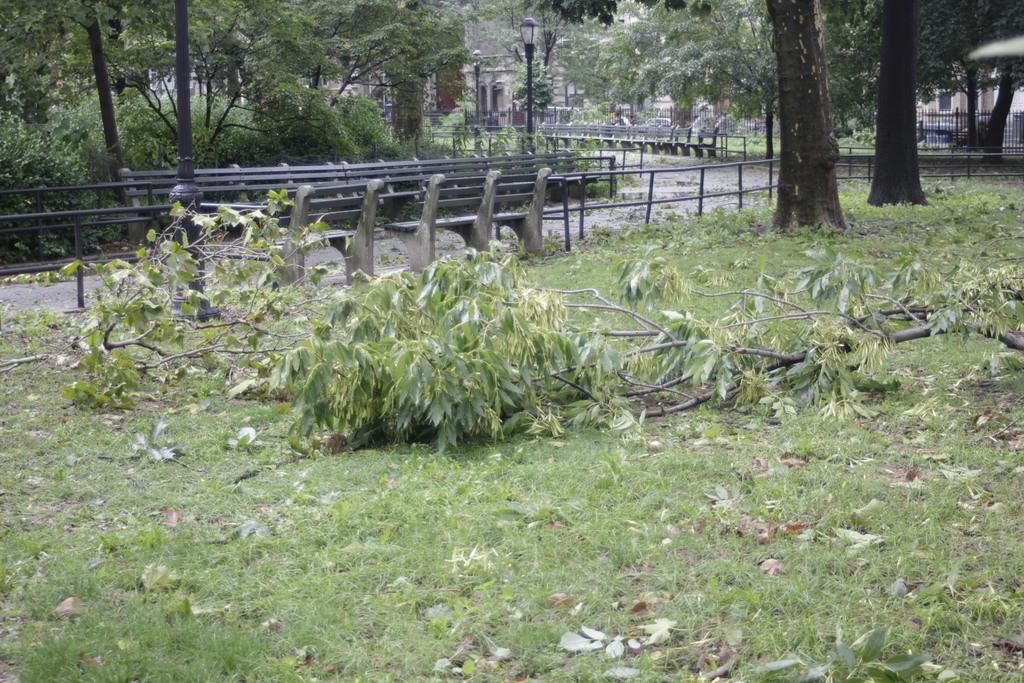What is on the grassy land in the image? There is a branch of a tree on the grassy land. What can be seen in the background of the image? There are benches, a fence, a pole, lights, and trees in the background. What is present on the grassy land besides the branch? There are dry leaves on the grassy land. Can you touch the kettle in the image? There is no kettle present in the image. What type of park is shown in the image? The image does not depict a park; it features a grassy land with a tree branch and background elements. 